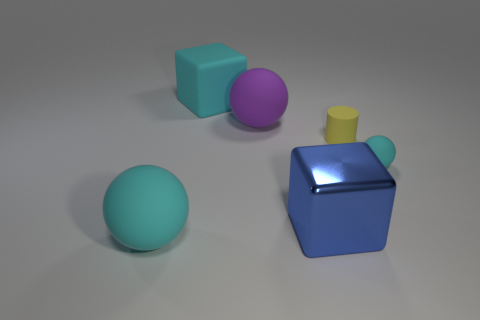Add 4 large purple objects. How many objects exist? 10 Subtract all cylinders. How many objects are left? 5 Add 2 brown spheres. How many brown spheres exist? 2 Subtract 0 red balls. How many objects are left? 6 Subtract all tiny cyan rubber balls. Subtract all purple balls. How many objects are left? 4 Add 4 yellow rubber cylinders. How many yellow rubber cylinders are left? 5 